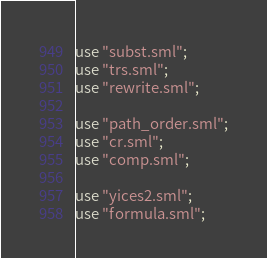Convert code to text. <code><loc_0><loc_0><loc_500><loc_500><_SML_>
use "subst.sml";
use "trs.sml";
use "rewrite.sml";

use "path_order.sml";
use "cr.sml";
use "comp.sml";

use "yices2.sml";
use "formula.sml";
</code> 